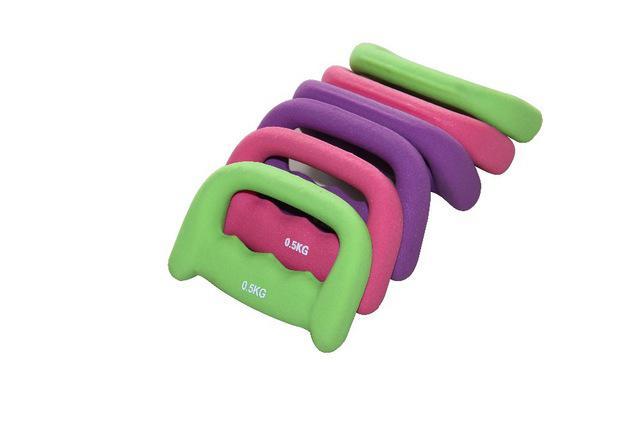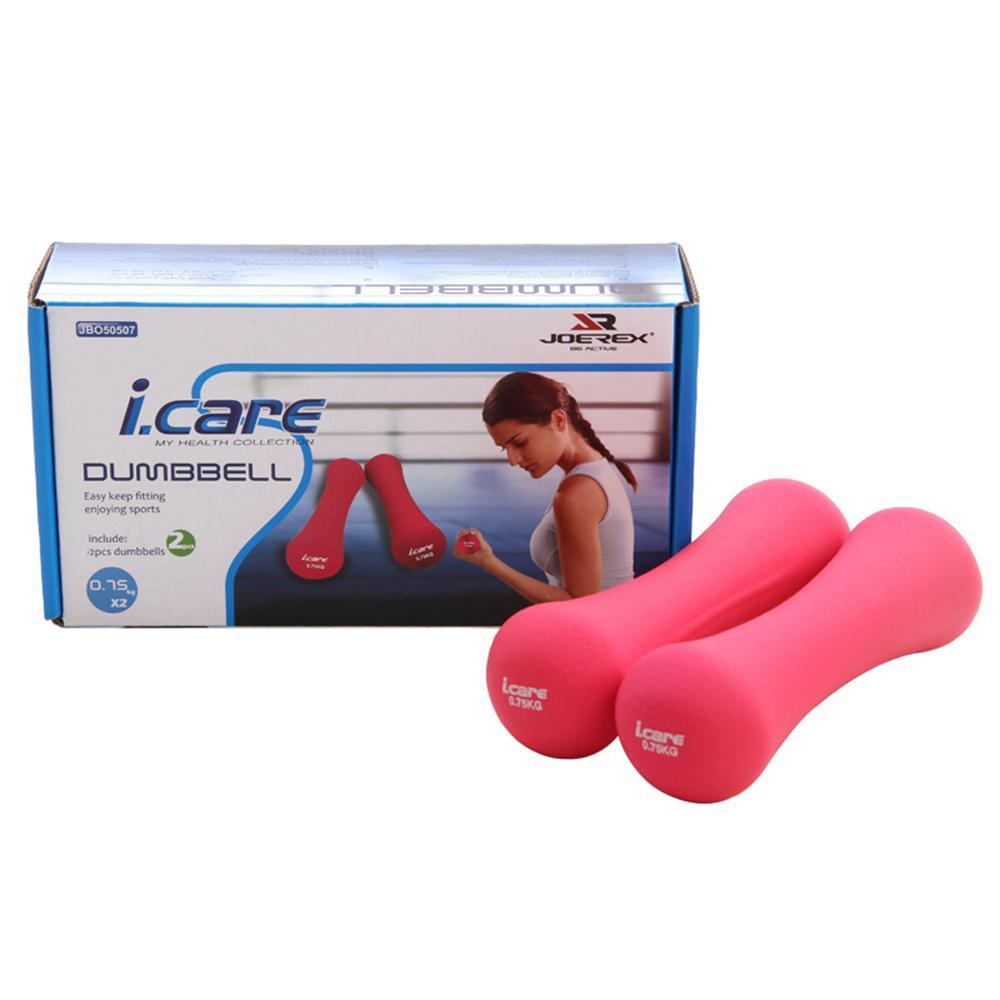The first image is the image on the left, the second image is the image on the right. For the images shown, is this caption "The left and right image contains the a total of eight weights." true? Answer yes or no. Yes. The first image is the image on the left, the second image is the image on the right. Given the left and right images, does the statement "One image contains two each of three different colors of barbell-shaped weights." hold true? Answer yes or no. No. 